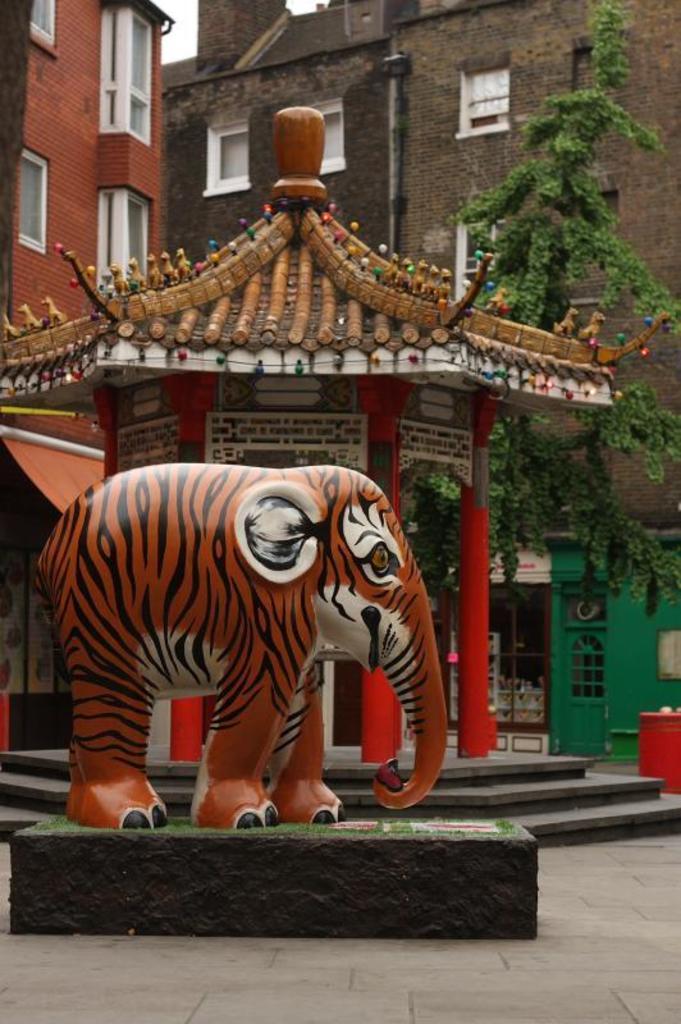Describe this image in one or two sentences. In this picture we can see a statue of an elephant on the road, buildings with windows and a tree. 